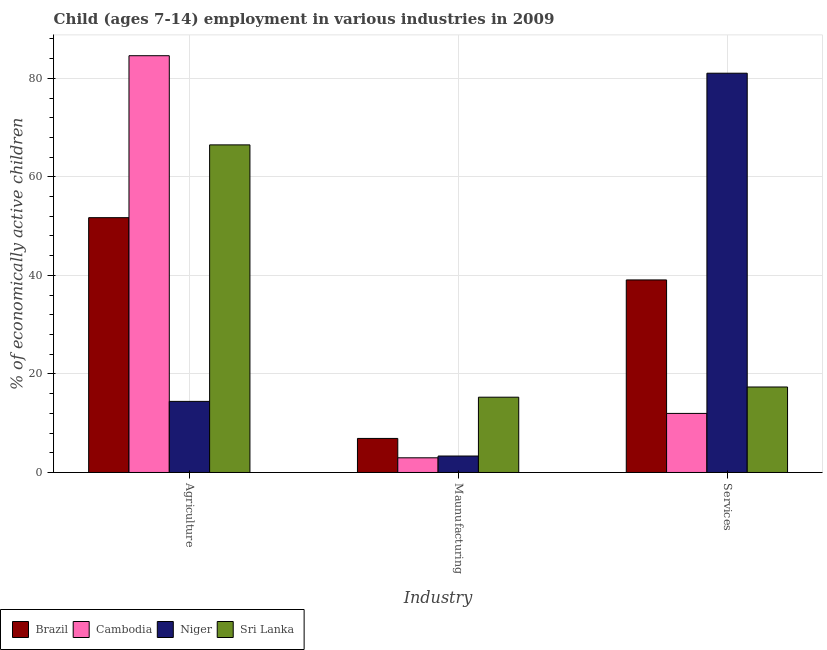How many different coloured bars are there?
Offer a terse response. 4. How many groups of bars are there?
Provide a short and direct response. 3. How many bars are there on the 2nd tick from the right?
Ensure brevity in your answer.  4. What is the label of the 1st group of bars from the left?
Offer a very short reply. Agriculture. What is the percentage of economically active children in services in Niger?
Your response must be concise. 81.04. Across all countries, what is the maximum percentage of economically active children in services?
Provide a short and direct response. 81.04. Across all countries, what is the minimum percentage of economically active children in services?
Provide a succinct answer. 11.99. In which country was the percentage of economically active children in agriculture maximum?
Ensure brevity in your answer.  Cambodia. In which country was the percentage of economically active children in manufacturing minimum?
Provide a succinct answer. Cambodia. What is the total percentage of economically active children in services in the graph?
Provide a short and direct response. 149.46. What is the difference between the percentage of economically active children in manufacturing in Niger and that in Cambodia?
Make the answer very short. 0.36. What is the difference between the percentage of economically active children in manufacturing in Niger and the percentage of economically active children in services in Brazil?
Offer a very short reply. -35.74. What is the average percentage of economically active children in agriculture per country?
Give a very brief answer. 54.31. What is the difference between the percentage of economically active children in agriculture and percentage of economically active children in manufacturing in Sri Lanka?
Ensure brevity in your answer.  51.21. What is the ratio of the percentage of economically active children in agriculture in Cambodia to that in Sri Lanka?
Offer a very short reply. 1.27. Is the percentage of economically active children in agriculture in Sri Lanka less than that in Brazil?
Provide a short and direct response. No. Is the difference between the percentage of economically active children in services in Niger and Cambodia greater than the difference between the percentage of economically active children in agriculture in Niger and Cambodia?
Make the answer very short. Yes. What is the difference between the highest and the second highest percentage of economically active children in services?
Offer a terse response. 41.96. What is the difference between the highest and the lowest percentage of economically active children in manufacturing?
Offer a terse response. 12.3. In how many countries, is the percentage of economically active children in agriculture greater than the average percentage of economically active children in agriculture taken over all countries?
Ensure brevity in your answer.  2. What does the 1st bar from the left in Agriculture represents?
Ensure brevity in your answer.  Brazil. What does the 1st bar from the right in Agriculture represents?
Your answer should be very brief. Sri Lanka. How many bars are there?
Ensure brevity in your answer.  12. Does the graph contain any zero values?
Offer a terse response. No. Where does the legend appear in the graph?
Offer a very short reply. Bottom left. How are the legend labels stacked?
Provide a short and direct response. Horizontal. What is the title of the graph?
Offer a terse response. Child (ages 7-14) employment in various industries in 2009. What is the label or title of the X-axis?
Your answer should be compact. Industry. What is the label or title of the Y-axis?
Your response must be concise. % of economically active children. What is the % of economically active children in Brazil in Agriculture?
Make the answer very short. 51.72. What is the % of economically active children in Cambodia in Agriculture?
Provide a succinct answer. 84.59. What is the % of economically active children in Niger in Agriculture?
Keep it short and to the point. 14.43. What is the % of economically active children of Sri Lanka in Agriculture?
Provide a succinct answer. 66.49. What is the % of economically active children of Brazil in Maunufacturing?
Offer a very short reply. 6.91. What is the % of economically active children in Cambodia in Maunufacturing?
Your answer should be very brief. 2.98. What is the % of economically active children of Niger in Maunufacturing?
Your response must be concise. 3.34. What is the % of economically active children of Sri Lanka in Maunufacturing?
Provide a succinct answer. 15.28. What is the % of economically active children of Brazil in Services?
Provide a succinct answer. 39.08. What is the % of economically active children of Cambodia in Services?
Offer a very short reply. 11.99. What is the % of economically active children of Niger in Services?
Keep it short and to the point. 81.04. What is the % of economically active children of Sri Lanka in Services?
Your answer should be compact. 17.35. Across all Industry, what is the maximum % of economically active children of Brazil?
Make the answer very short. 51.72. Across all Industry, what is the maximum % of economically active children of Cambodia?
Your response must be concise. 84.59. Across all Industry, what is the maximum % of economically active children in Niger?
Offer a very short reply. 81.04. Across all Industry, what is the maximum % of economically active children of Sri Lanka?
Give a very brief answer. 66.49. Across all Industry, what is the minimum % of economically active children of Brazil?
Make the answer very short. 6.91. Across all Industry, what is the minimum % of economically active children of Cambodia?
Your response must be concise. 2.98. Across all Industry, what is the minimum % of economically active children in Niger?
Keep it short and to the point. 3.34. Across all Industry, what is the minimum % of economically active children in Sri Lanka?
Provide a short and direct response. 15.28. What is the total % of economically active children of Brazil in the graph?
Ensure brevity in your answer.  97.71. What is the total % of economically active children in Cambodia in the graph?
Make the answer very short. 99.56. What is the total % of economically active children in Niger in the graph?
Provide a succinct answer. 98.81. What is the total % of economically active children in Sri Lanka in the graph?
Your answer should be compact. 99.12. What is the difference between the % of economically active children of Brazil in Agriculture and that in Maunufacturing?
Your response must be concise. 44.81. What is the difference between the % of economically active children in Cambodia in Agriculture and that in Maunufacturing?
Provide a succinct answer. 81.61. What is the difference between the % of economically active children in Niger in Agriculture and that in Maunufacturing?
Your response must be concise. 11.09. What is the difference between the % of economically active children of Sri Lanka in Agriculture and that in Maunufacturing?
Give a very brief answer. 51.21. What is the difference between the % of economically active children of Brazil in Agriculture and that in Services?
Your answer should be compact. 12.64. What is the difference between the % of economically active children in Cambodia in Agriculture and that in Services?
Your answer should be very brief. 72.6. What is the difference between the % of economically active children of Niger in Agriculture and that in Services?
Offer a terse response. -66.61. What is the difference between the % of economically active children of Sri Lanka in Agriculture and that in Services?
Ensure brevity in your answer.  49.14. What is the difference between the % of economically active children in Brazil in Maunufacturing and that in Services?
Your answer should be compact. -32.17. What is the difference between the % of economically active children of Cambodia in Maunufacturing and that in Services?
Ensure brevity in your answer.  -9.01. What is the difference between the % of economically active children of Niger in Maunufacturing and that in Services?
Provide a succinct answer. -77.7. What is the difference between the % of economically active children in Sri Lanka in Maunufacturing and that in Services?
Make the answer very short. -2.07. What is the difference between the % of economically active children of Brazil in Agriculture and the % of economically active children of Cambodia in Maunufacturing?
Ensure brevity in your answer.  48.74. What is the difference between the % of economically active children of Brazil in Agriculture and the % of economically active children of Niger in Maunufacturing?
Provide a succinct answer. 48.38. What is the difference between the % of economically active children of Brazil in Agriculture and the % of economically active children of Sri Lanka in Maunufacturing?
Offer a very short reply. 36.44. What is the difference between the % of economically active children in Cambodia in Agriculture and the % of economically active children in Niger in Maunufacturing?
Your response must be concise. 81.25. What is the difference between the % of economically active children in Cambodia in Agriculture and the % of economically active children in Sri Lanka in Maunufacturing?
Your answer should be compact. 69.31. What is the difference between the % of economically active children in Niger in Agriculture and the % of economically active children in Sri Lanka in Maunufacturing?
Offer a very short reply. -0.85. What is the difference between the % of economically active children in Brazil in Agriculture and the % of economically active children in Cambodia in Services?
Give a very brief answer. 39.73. What is the difference between the % of economically active children of Brazil in Agriculture and the % of economically active children of Niger in Services?
Your answer should be very brief. -29.32. What is the difference between the % of economically active children of Brazil in Agriculture and the % of economically active children of Sri Lanka in Services?
Offer a terse response. 34.37. What is the difference between the % of economically active children of Cambodia in Agriculture and the % of economically active children of Niger in Services?
Keep it short and to the point. 3.55. What is the difference between the % of economically active children of Cambodia in Agriculture and the % of economically active children of Sri Lanka in Services?
Give a very brief answer. 67.24. What is the difference between the % of economically active children in Niger in Agriculture and the % of economically active children in Sri Lanka in Services?
Your answer should be compact. -2.92. What is the difference between the % of economically active children in Brazil in Maunufacturing and the % of economically active children in Cambodia in Services?
Your answer should be compact. -5.08. What is the difference between the % of economically active children of Brazil in Maunufacturing and the % of economically active children of Niger in Services?
Your answer should be very brief. -74.13. What is the difference between the % of economically active children in Brazil in Maunufacturing and the % of economically active children in Sri Lanka in Services?
Ensure brevity in your answer.  -10.44. What is the difference between the % of economically active children in Cambodia in Maunufacturing and the % of economically active children in Niger in Services?
Your answer should be compact. -78.06. What is the difference between the % of economically active children in Cambodia in Maunufacturing and the % of economically active children in Sri Lanka in Services?
Offer a terse response. -14.37. What is the difference between the % of economically active children of Niger in Maunufacturing and the % of economically active children of Sri Lanka in Services?
Offer a very short reply. -14.01. What is the average % of economically active children in Brazil per Industry?
Provide a short and direct response. 32.57. What is the average % of economically active children of Cambodia per Industry?
Your answer should be very brief. 33.19. What is the average % of economically active children in Niger per Industry?
Make the answer very short. 32.94. What is the average % of economically active children in Sri Lanka per Industry?
Your answer should be very brief. 33.04. What is the difference between the % of economically active children in Brazil and % of economically active children in Cambodia in Agriculture?
Ensure brevity in your answer.  -32.87. What is the difference between the % of economically active children of Brazil and % of economically active children of Niger in Agriculture?
Make the answer very short. 37.29. What is the difference between the % of economically active children in Brazil and % of economically active children in Sri Lanka in Agriculture?
Provide a succinct answer. -14.77. What is the difference between the % of economically active children of Cambodia and % of economically active children of Niger in Agriculture?
Your answer should be very brief. 70.16. What is the difference between the % of economically active children in Cambodia and % of economically active children in Sri Lanka in Agriculture?
Keep it short and to the point. 18.1. What is the difference between the % of economically active children in Niger and % of economically active children in Sri Lanka in Agriculture?
Make the answer very short. -52.06. What is the difference between the % of economically active children of Brazil and % of economically active children of Cambodia in Maunufacturing?
Your answer should be compact. 3.93. What is the difference between the % of economically active children of Brazil and % of economically active children of Niger in Maunufacturing?
Make the answer very short. 3.57. What is the difference between the % of economically active children in Brazil and % of economically active children in Sri Lanka in Maunufacturing?
Give a very brief answer. -8.37. What is the difference between the % of economically active children in Cambodia and % of economically active children in Niger in Maunufacturing?
Make the answer very short. -0.36. What is the difference between the % of economically active children in Cambodia and % of economically active children in Sri Lanka in Maunufacturing?
Your response must be concise. -12.3. What is the difference between the % of economically active children in Niger and % of economically active children in Sri Lanka in Maunufacturing?
Keep it short and to the point. -11.94. What is the difference between the % of economically active children in Brazil and % of economically active children in Cambodia in Services?
Offer a very short reply. 27.09. What is the difference between the % of economically active children of Brazil and % of economically active children of Niger in Services?
Your response must be concise. -41.96. What is the difference between the % of economically active children in Brazil and % of economically active children in Sri Lanka in Services?
Keep it short and to the point. 21.73. What is the difference between the % of economically active children in Cambodia and % of economically active children in Niger in Services?
Offer a terse response. -69.05. What is the difference between the % of economically active children in Cambodia and % of economically active children in Sri Lanka in Services?
Your answer should be compact. -5.36. What is the difference between the % of economically active children in Niger and % of economically active children in Sri Lanka in Services?
Provide a short and direct response. 63.69. What is the ratio of the % of economically active children in Brazil in Agriculture to that in Maunufacturing?
Provide a succinct answer. 7.48. What is the ratio of the % of economically active children in Cambodia in Agriculture to that in Maunufacturing?
Provide a succinct answer. 28.39. What is the ratio of the % of economically active children of Niger in Agriculture to that in Maunufacturing?
Keep it short and to the point. 4.32. What is the ratio of the % of economically active children of Sri Lanka in Agriculture to that in Maunufacturing?
Offer a terse response. 4.35. What is the ratio of the % of economically active children in Brazil in Agriculture to that in Services?
Offer a terse response. 1.32. What is the ratio of the % of economically active children of Cambodia in Agriculture to that in Services?
Keep it short and to the point. 7.05. What is the ratio of the % of economically active children of Niger in Agriculture to that in Services?
Provide a short and direct response. 0.18. What is the ratio of the % of economically active children in Sri Lanka in Agriculture to that in Services?
Offer a very short reply. 3.83. What is the ratio of the % of economically active children in Brazil in Maunufacturing to that in Services?
Make the answer very short. 0.18. What is the ratio of the % of economically active children of Cambodia in Maunufacturing to that in Services?
Offer a very short reply. 0.25. What is the ratio of the % of economically active children of Niger in Maunufacturing to that in Services?
Ensure brevity in your answer.  0.04. What is the ratio of the % of economically active children in Sri Lanka in Maunufacturing to that in Services?
Ensure brevity in your answer.  0.88. What is the difference between the highest and the second highest % of economically active children of Brazil?
Provide a short and direct response. 12.64. What is the difference between the highest and the second highest % of economically active children in Cambodia?
Offer a terse response. 72.6. What is the difference between the highest and the second highest % of economically active children in Niger?
Provide a succinct answer. 66.61. What is the difference between the highest and the second highest % of economically active children of Sri Lanka?
Ensure brevity in your answer.  49.14. What is the difference between the highest and the lowest % of economically active children in Brazil?
Ensure brevity in your answer.  44.81. What is the difference between the highest and the lowest % of economically active children of Cambodia?
Provide a short and direct response. 81.61. What is the difference between the highest and the lowest % of economically active children of Niger?
Your answer should be compact. 77.7. What is the difference between the highest and the lowest % of economically active children of Sri Lanka?
Ensure brevity in your answer.  51.21. 